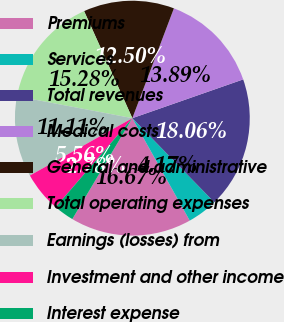Convert chart to OTSL. <chart><loc_0><loc_0><loc_500><loc_500><pie_chart><fcel>Premiums<fcel>Services<fcel>Total revenues<fcel>Medical costs<fcel>General and administrative<fcel>Total operating expenses<fcel>Earnings (losses) from<fcel>Investment and other income<fcel>Interest expense<nl><fcel>16.67%<fcel>4.17%<fcel>18.06%<fcel>13.89%<fcel>12.5%<fcel>15.28%<fcel>11.11%<fcel>5.56%<fcel>2.78%<nl></chart> 